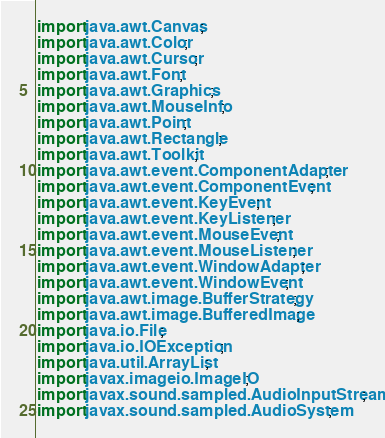Convert code to text. <code><loc_0><loc_0><loc_500><loc_500><_Java_>import java.awt.Canvas;
import java.awt.Color;
import java.awt.Cursor;
import java.awt.Font;
import java.awt.Graphics;
import java.awt.MouseInfo;
import java.awt.Point;
import java.awt.Rectangle;
import java.awt.Toolkit;
import java.awt.event.ComponentAdapter;
import java.awt.event.ComponentEvent;
import java.awt.event.KeyEvent;
import java.awt.event.KeyListener;
import java.awt.event.MouseEvent;
import java.awt.event.MouseListener;
import java.awt.event.WindowAdapter;
import java.awt.event.WindowEvent;
import java.awt.image.BufferStrategy;
import java.awt.image.BufferedImage;
import java.io.File;
import java.io.IOException;
import java.util.ArrayList;
import javax.imageio.ImageIO;
import javax.sound.sampled.AudioInputStream;
import javax.sound.sampled.AudioSystem;</code> 